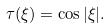Convert formula to latex. <formula><loc_0><loc_0><loc_500><loc_500>\tau ( \xi ) = \cos | \xi | .</formula> 